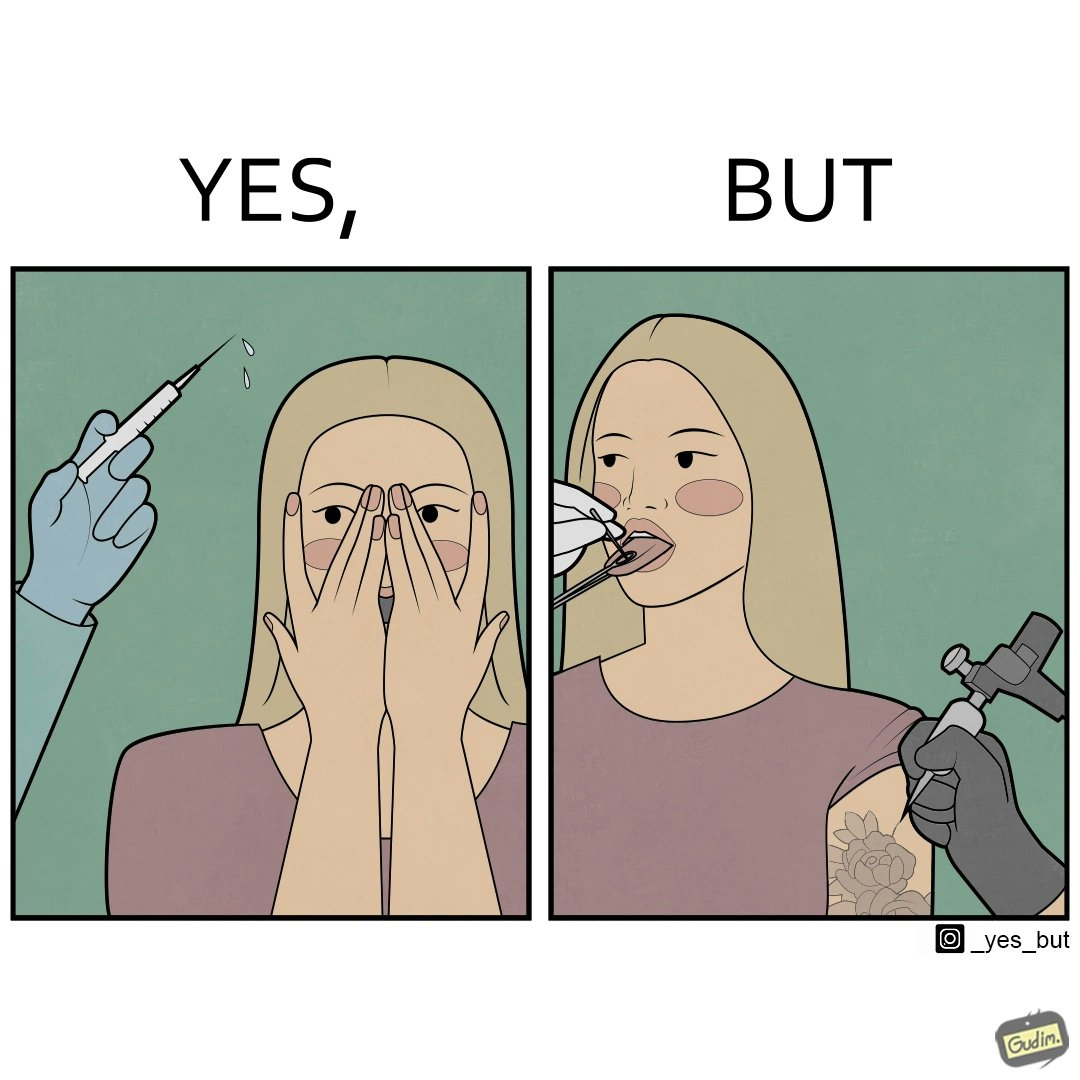Provide a description of this image. The image is funny becuase while the woman is scared of getting an injection which is for her benefit, she is not afraid of getting a piercing or a tattoo which are not going to help her in any way. 